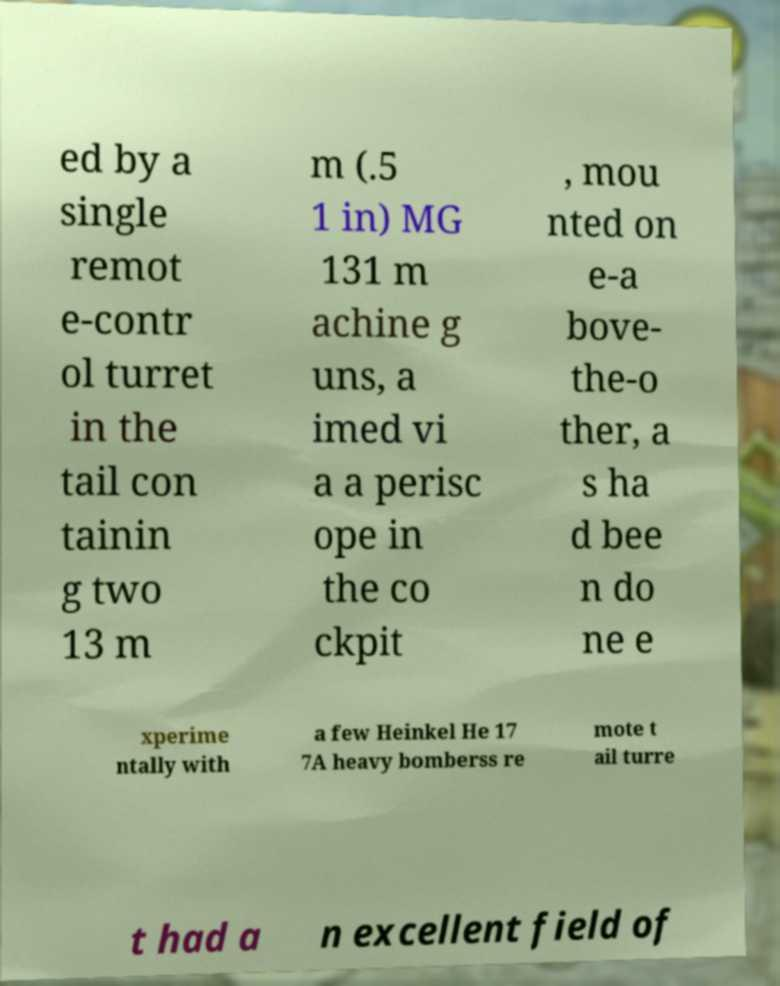Can you read and provide the text displayed in the image?This photo seems to have some interesting text. Can you extract and type it out for me? ed by a single remot e-contr ol turret in the tail con tainin g two 13 m m (.5 1 in) MG 131 m achine g uns, a imed vi a a perisc ope in the co ckpit , mou nted on e-a bove- the-o ther, a s ha d bee n do ne e xperime ntally with a few Heinkel He 17 7A heavy bomberss re mote t ail turre t had a n excellent field of 